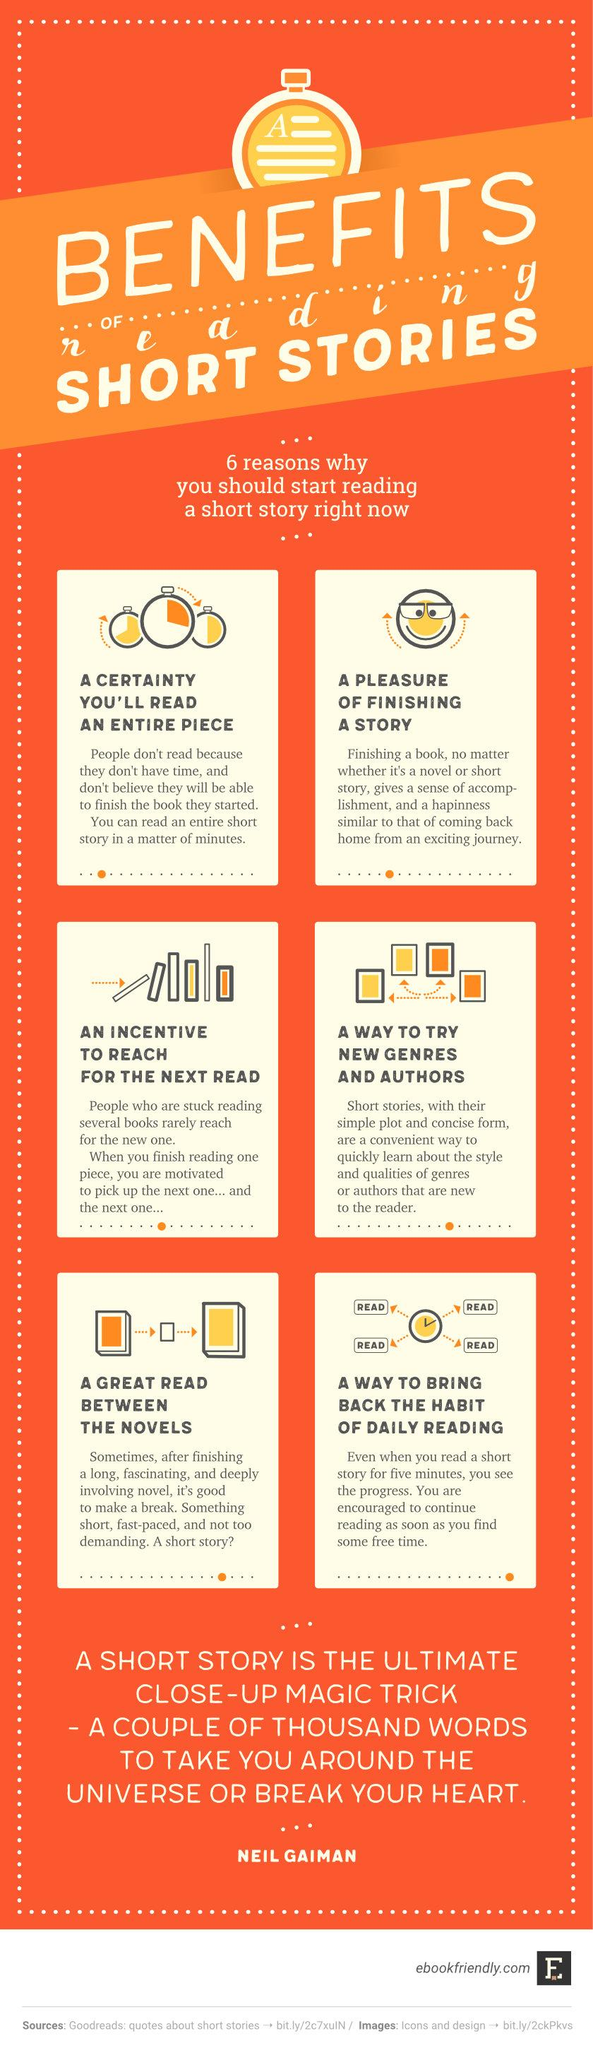Identify some key points in this picture. Reading short stories offers a fourth benefit of trying new genres and authors, which is an opportunity to expand your literary horizons and discover new writers and styles. Reading short stories provides a fifth benefit, which is a great read between novels. Reading short stories has the benefit of providing an incentive to continue reading, motivating the reader to reach for the next book or story to enjoy. 